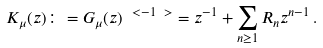Convert formula to latex. <formula><loc_0><loc_0><loc_500><loc_500>K _ { \mu } ( z ) \colon = G _ { \mu } ( z ) ^ { \ < - 1 \ > } = z ^ { - 1 } + \sum _ { n \geq 1 } R _ { n } z ^ { n - 1 } \, .</formula> 